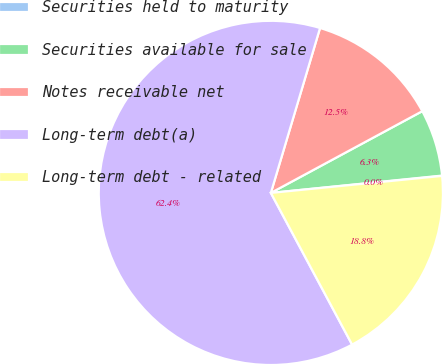<chart> <loc_0><loc_0><loc_500><loc_500><pie_chart><fcel>Securities held to maturity<fcel>Securities available for sale<fcel>Notes receivable net<fcel>Long-term debt(a)<fcel>Long-term debt - related<nl><fcel>0.03%<fcel>6.27%<fcel>12.51%<fcel>62.44%<fcel>18.75%<nl></chart> 